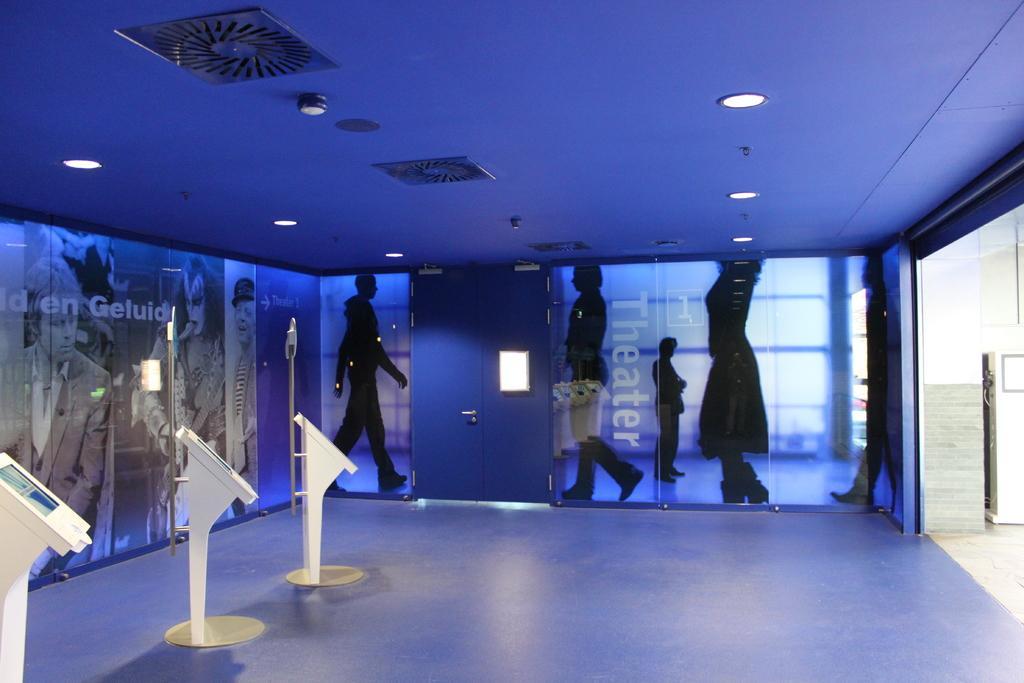How would you summarize this image in a sentence or two? In this image I can see a door. At the top I can see the lights on the wall. 